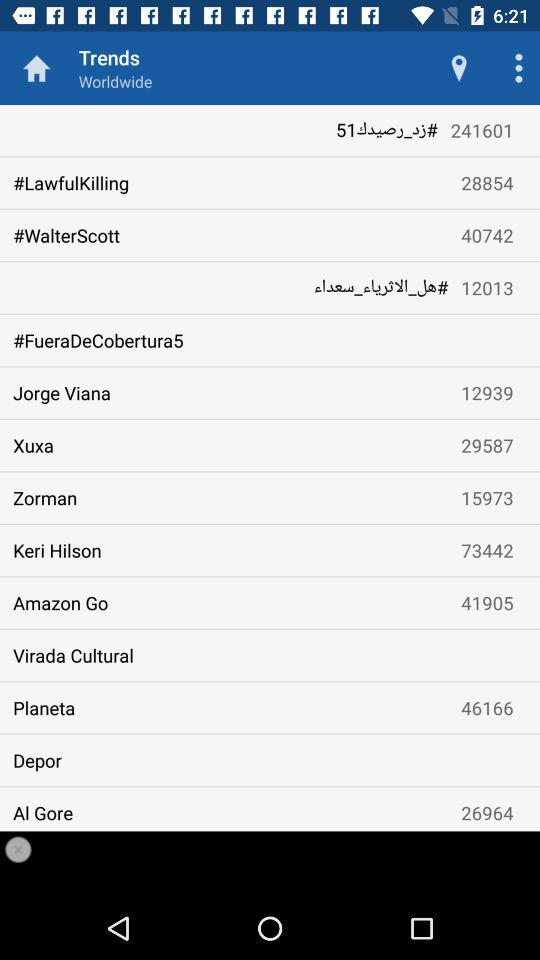What trend is followed by 40742 people? The trend "#Walter Scott" is followed by 40742 people. 